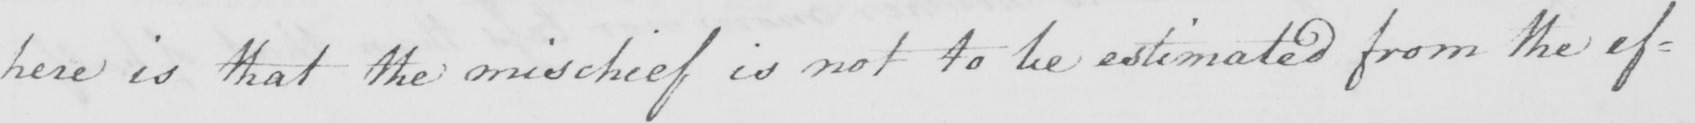What text is written in this handwritten line? here is that the mischief is not to be estimated from the ef= 